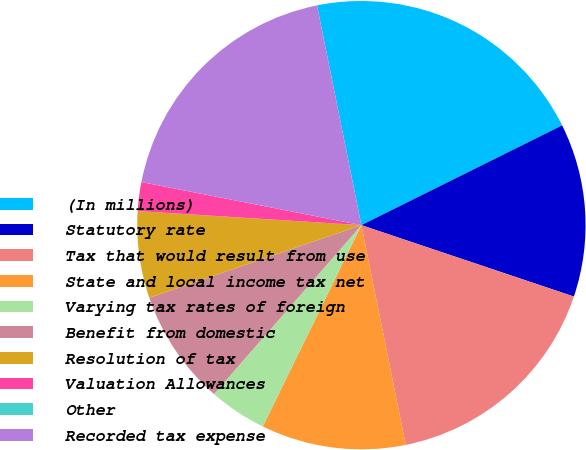Convert chart. <chart><loc_0><loc_0><loc_500><loc_500><pie_chart><fcel>(In millions)<fcel>Statutory rate<fcel>Tax that would result from use<fcel>State and local income tax net<fcel>Varying tax rates of foreign<fcel>Benefit from domestic<fcel>Resolution of tax<fcel>Valuation Allowances<fcel>Other<fcel>Recorded tax expense<nl><fcel>20.83%<fcel>12.5%<fcel>16.67%<fcel>10.42%<fcel>4.17%<fcel>8.33%<fcel>6.25%<fcel>2.08%<fcel>0.0%<fcel>18.75%<nl></chart> 